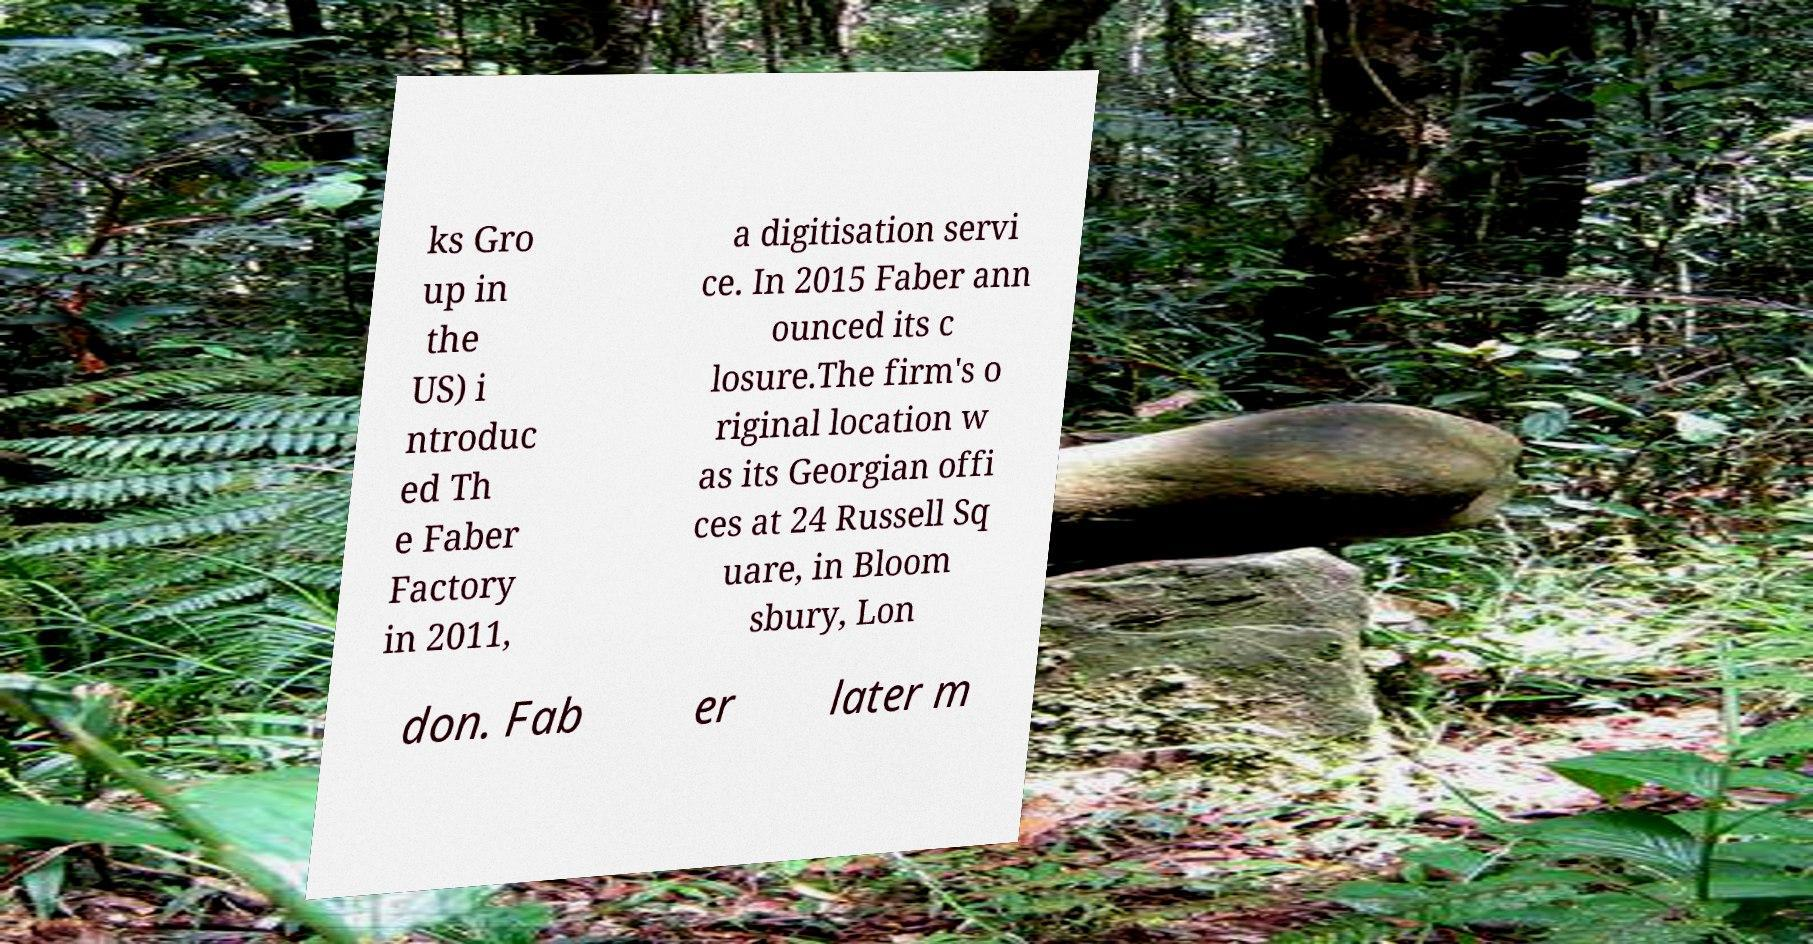Can you read and provide the text displayed in the image?This photo seems to have some interesting text. Can you extract and type it out for me? ks Gro up in the US) i ntroduc ed Th e Faber Factory in 2011, a digitisation servi ce. In 2015 Faber ann ounced its c losure.The firm's o riginal location w as its Georgian offi ces at 24 Russell Sq uare, in Bloom sbury, Lon don. Fab er later m 